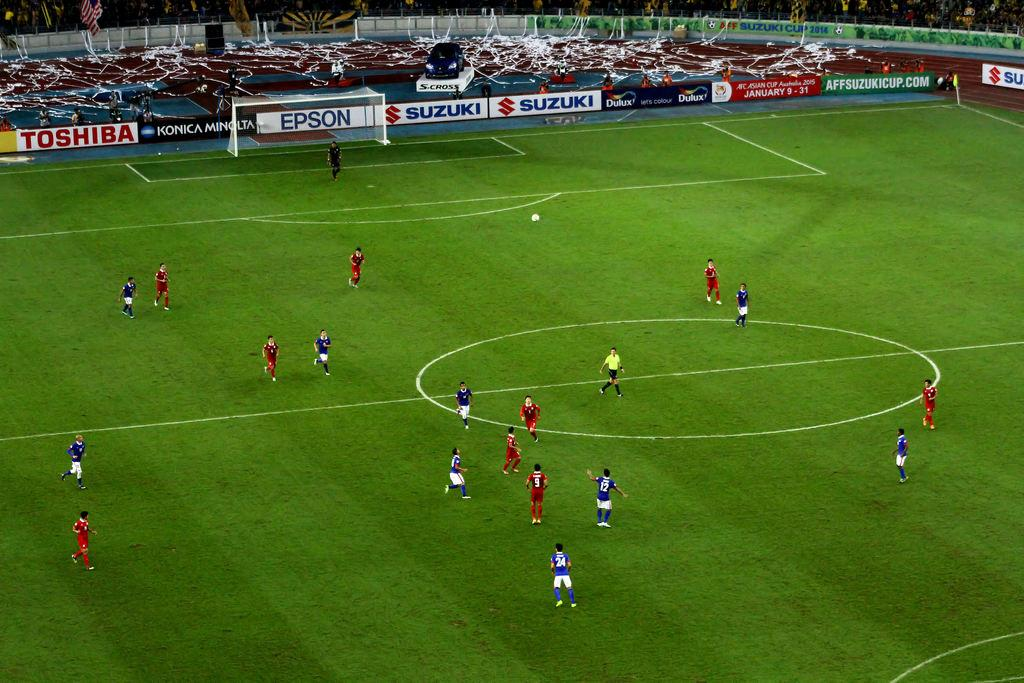<image>
Create a compact narrative representing the image presented. A soccer game takes place while there are advertisements for Toshiba and Epson in the background. 